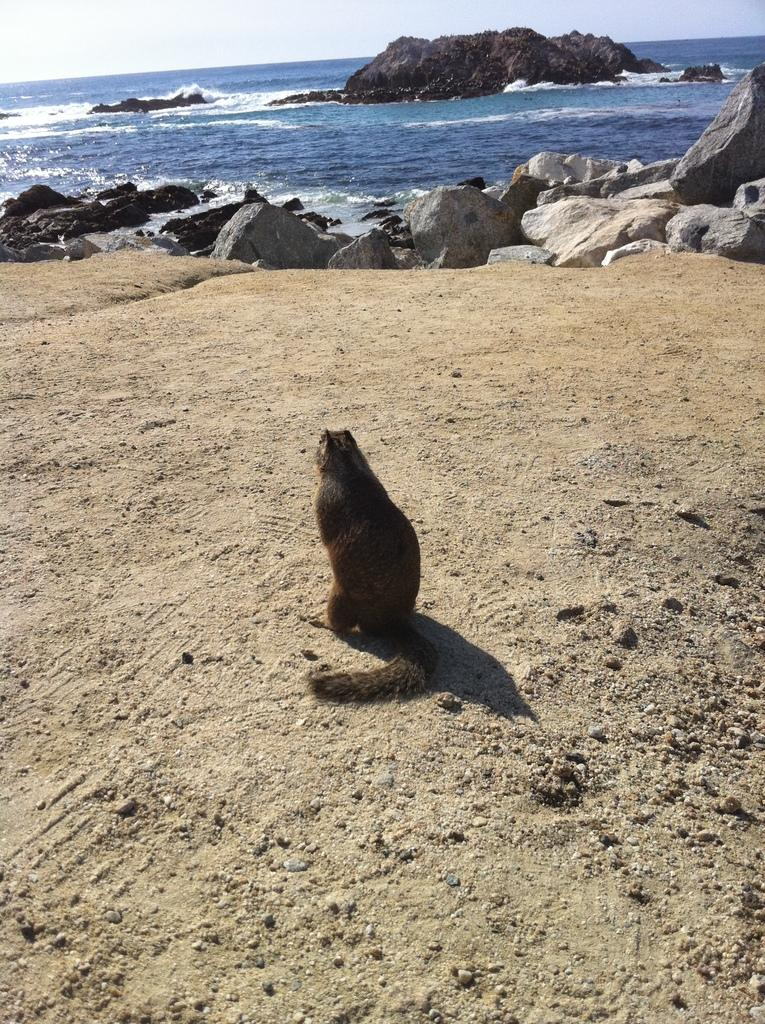What type of animal can be seen on the ground in the image? There is an animal on the ground in the image, but the specific type cannot be determined from the provided facts. What can be seen in the background of the image? There are rocks, water, and the sky visible in the background of the image. What type of oatmeal is being served in the scene? There is no oatmeal present in the image, nor is there any indication of a scene or a meal being served. 